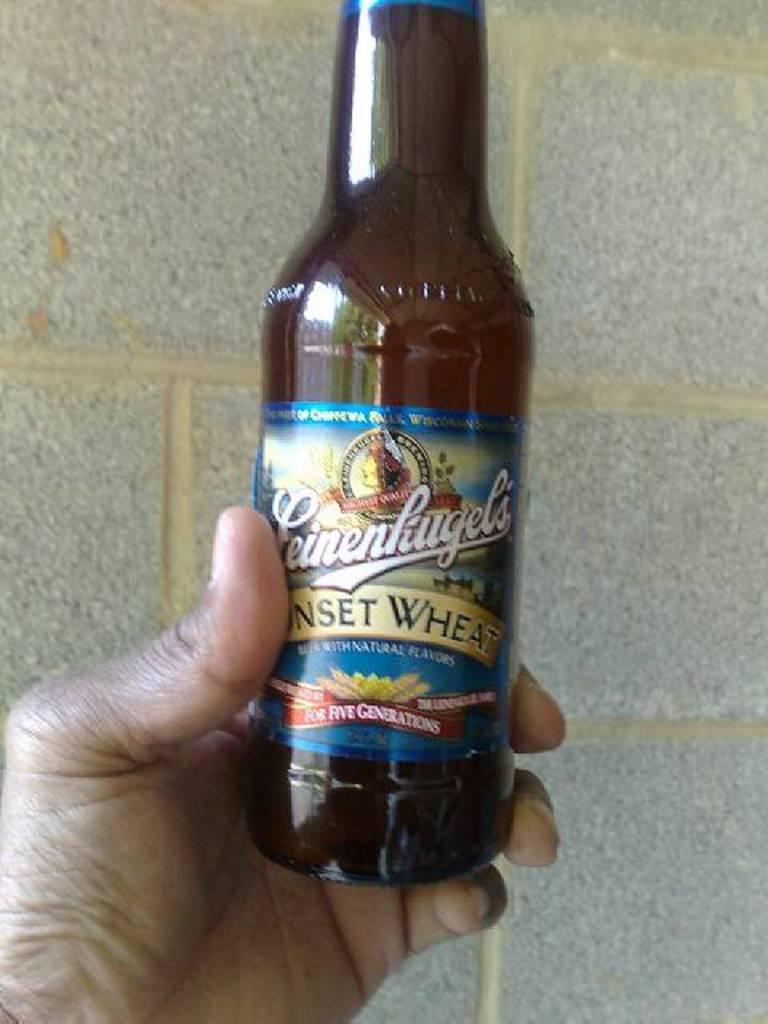What beer is this?
Keep it short and to the point. Leinenliugels. 